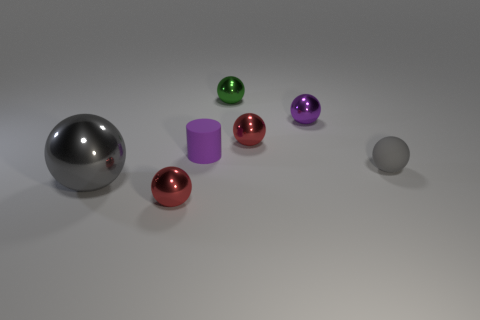What might be the context or setting of these objects? Based on the neutral background and the placement of the objects, it looks to be a controlled environment, possibly for a display or for photographic purposes to highlight their shapes and colors. 